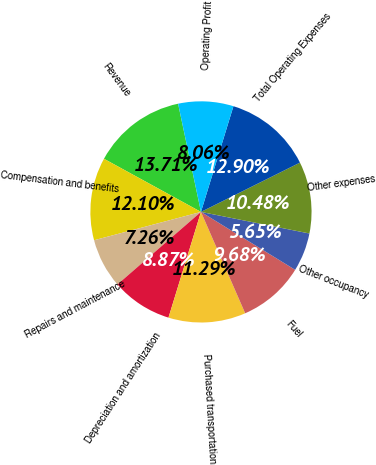<chart> <loc_0><loc_0><loc_500><loc_500><pie_chart><fcel>Revenue<fcel>Compensation and benefits<fcel>Repairs and maintenance<fcel>Depreciation and amortization<fcel>Purchased transportation<fcel>Fuel<fcel>Other occupancy<fcel>Other expenses<fcel>Total Operating Expenses<fcel>Operating Profit<nl><fcel>13.71%<fcel>12.1%<fcel>7.26%<fcel>8.87%<fcel>11.29%<fcel>9.68%<fcel>5.65%<fcel>10.48%<fcel>12.9%<fcel>8.06%<nl></chart> 